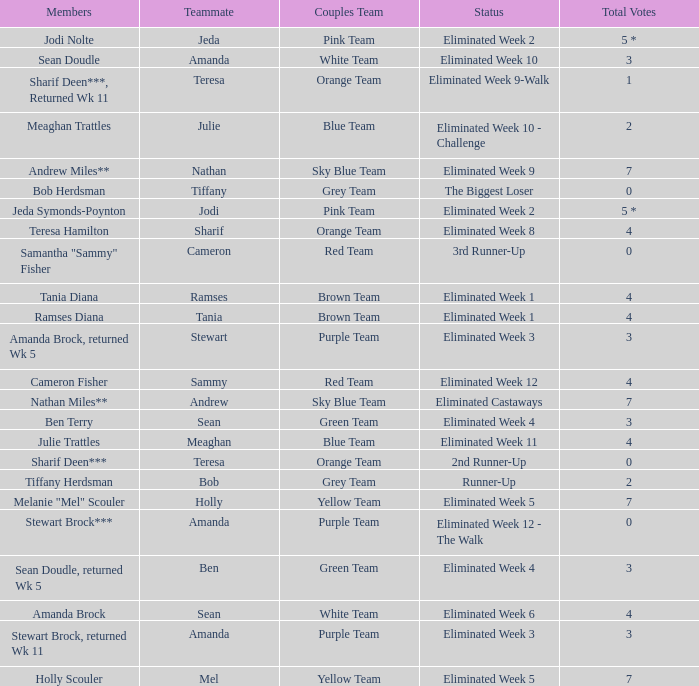On the purple team, who had a total vote count of zero? Eliminated Week 12 - The Walk. 